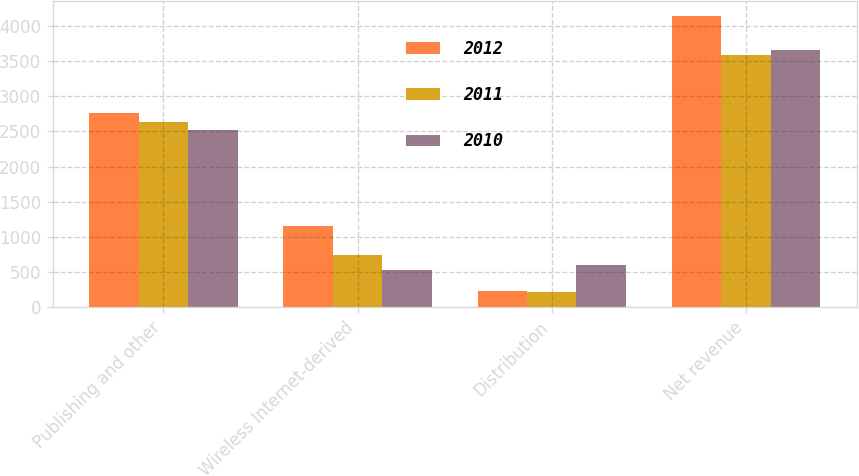<chart> <loc_0><loc_0><loc_500><loc_500><stacked_bar_chart><ecel><fcel>Publishing and other<fcel>Wireless Internet-derived<fcel>Distribution<fcel>Net revenue<nl><fcel>2012<fcel>2761<fcel>1159<fcel>223<fcel>4143<nl><fcel>2011<fcel>2632<fcel>743<fcel>214<fcel>3589<nl><fcel>2010<fcel>2526<fcel>522<fcel>606<fcel>3654<nl></chart> 